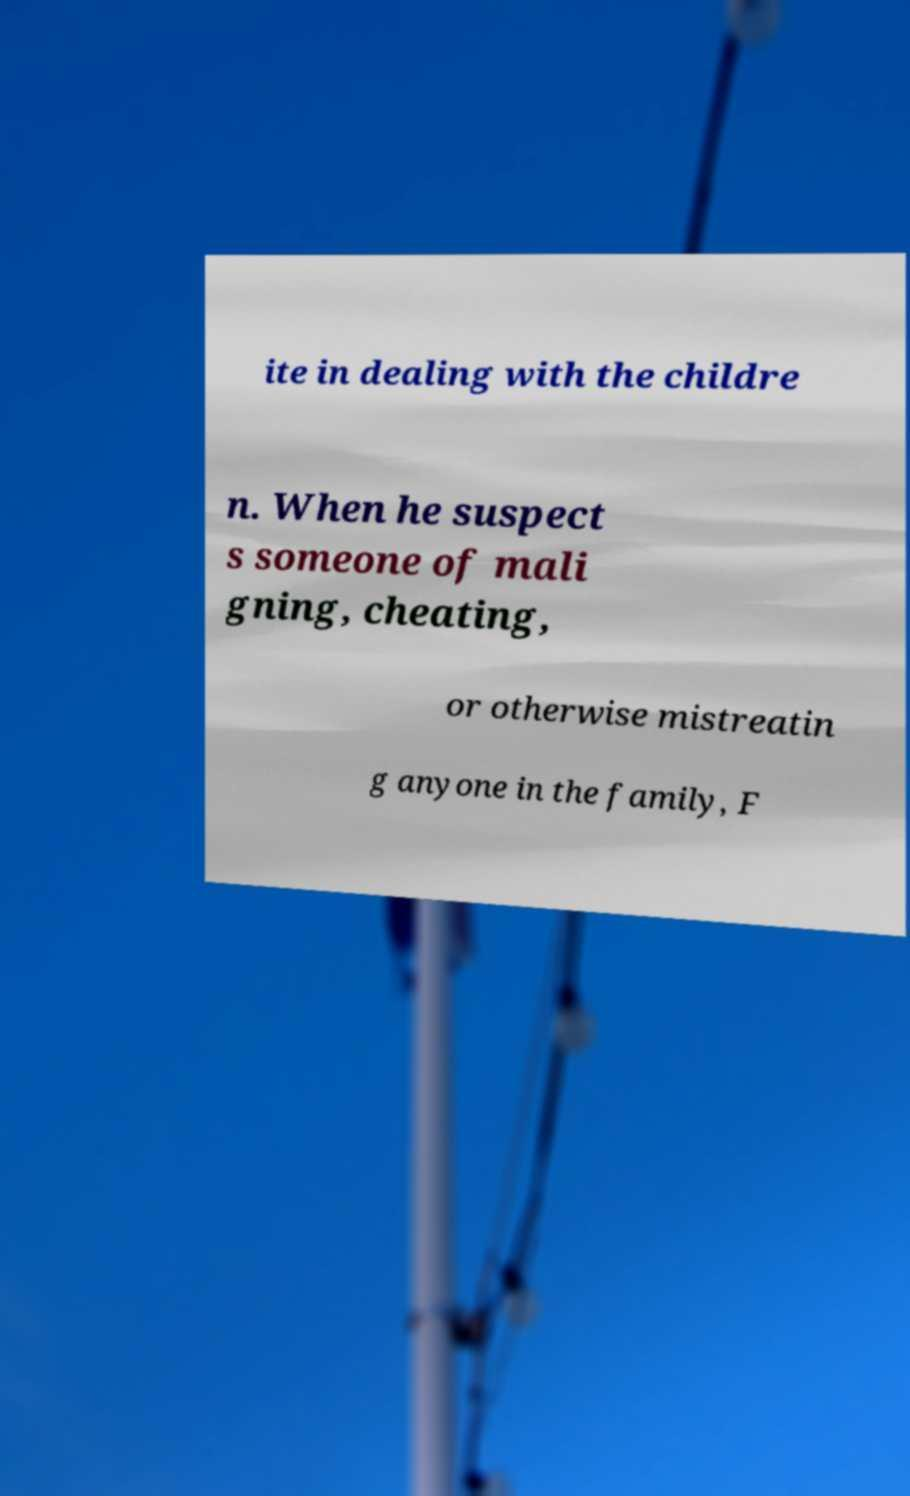Please read and relay the text visible in this image. What does it say? ite in dealing with the childre n. When he suspect s someone of mali gning, cheating, or otherwise mistreatin g anyone in the family, F 